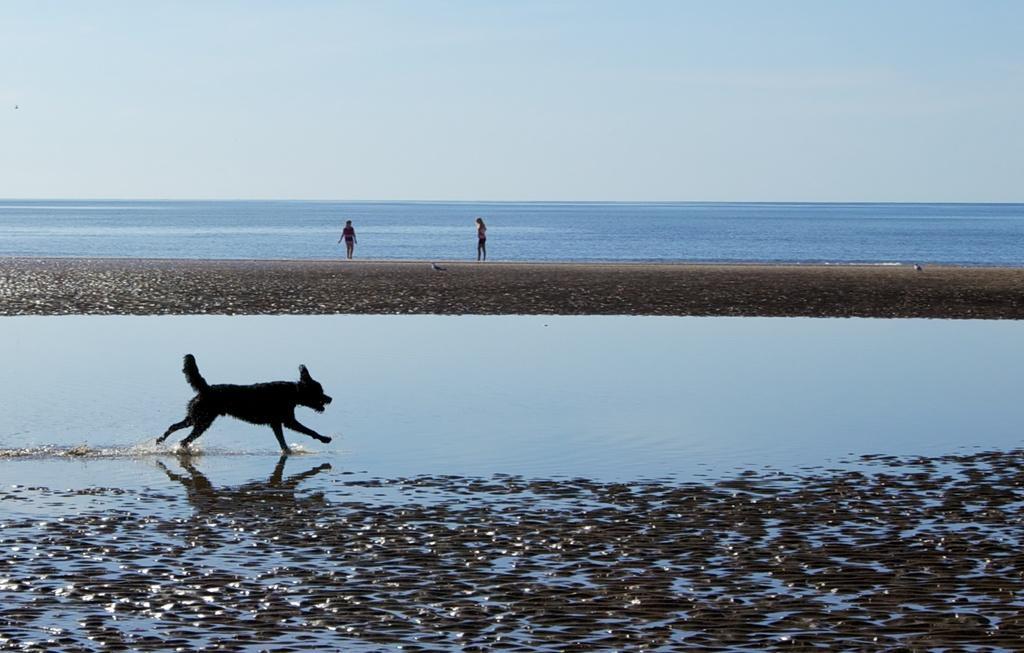Can you describe this image briefly? This picture shows a dog running in the water and we see couple woman and we see a cloudy sky. 